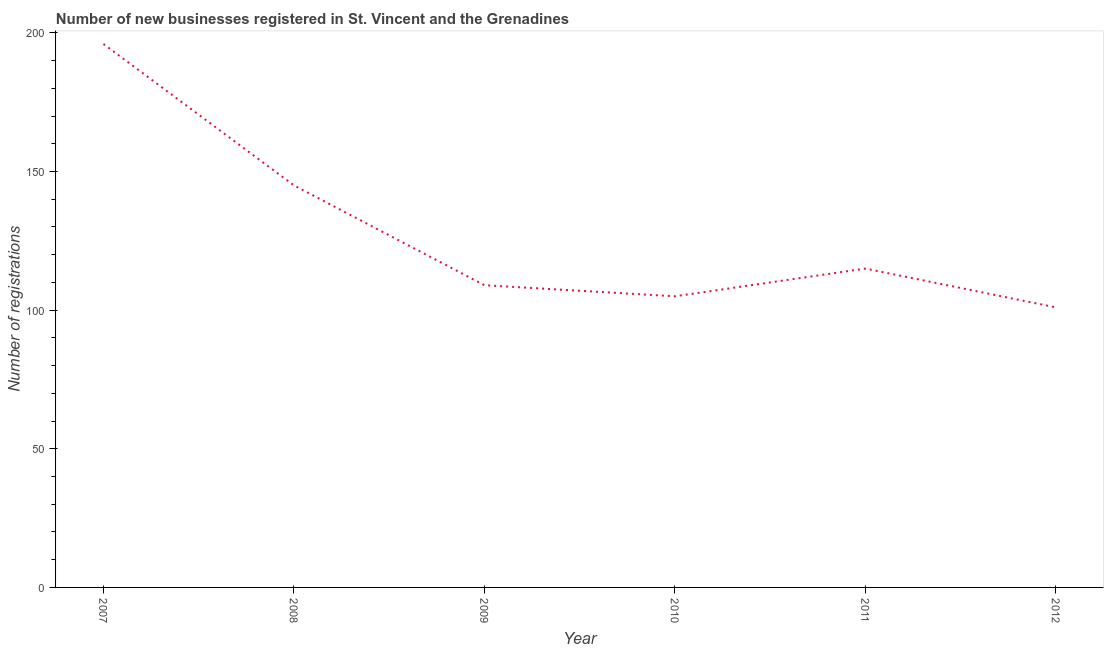What is the number of new business registrations in 2010?
Give a very brief answer. 105. Across all years, what is the maximum number of new business registrations?
Your answer should be compact. 196. Across all years, what is the minimum number of new business registrations?
Keep it short and to the point. 101. In which year was the number of new business registrations minimum?
Offer a terse response. 2012. What is the sum of the number of new business registrations?
Ensure brevity in your answer.  771. What is the difference between the number of new business registrations in 2010 and 2011?
Provide a short and direct response. -10. What is the average number of new business registrations per year?
Keep it short and to the point. 128.5. What is the median number of new business registrations?
Your answer should be very brief. 112. What is the ratio of the number of new business registrations in 2007 to that in 2011?
Ensure brevity in your answer.  1.7. Is the number of new business registrations in 2008 less than that in 2011?
Your answer should be compact. No. Is the difference between the number of new business registrations in 2007 and 2008 greater than the difference between any two years?
Provide a short and direct response. No. Is the sum of the number of new business registrations in 2007 and 2012 greater than the maximum number of new business registrations across all years?
Provide a succinct answer. Yes. What is the difference between the highest and the lowest number of new business registrations?
Make the answer very short. 95. In how many years, is the number of new business registrations greater than the average number of new business registrations taken over all years?
Provide a succinct answer. 2. How many lines are there?
Your answer should be very brief. 1. How many years are there in the graph?
Provide a short and direct response. 6. What is the difference between two consecutive major ticks on the Y-axis?
Offer a terse response. 50. Does the graph contain grids?
Give a very brief answer. No. What is the title of the graph?
Offer a terse response. Number of new businesses registered in St. Vincent and the Grenadines. What is the label or title of the Y-axis?
Keep it short and to the point. Number of registrations. What is the Number of registrations of 2007?
Offer a very short reply. 196. What is the Number of registrations of 2008?
Offer a very short reply. 145. What is the Number of registrations in 2009?
Your response must be concise. 109. What is the Number of registrations of 2010?
Your answer should be very brief. 105. What is the Number of registrations in 2011?
Ensure brevity in your answer.  115. What is the Number of registrations in 2012?
Offer a terse response. 101. What is the difference between the Number of registrations in 2007 and 2008?
Your answer should be compact. 51. What is the difference between the Number of registrations in 2007 and 2010?
Your answer should be compact. 91. What is the difference between the Number of registrations in 2008 and 2011?
Make the answer very short. 30. What is the difference between the Number of registrations in 2009 and 2012?
Ensure brevity in your answer.  8. What is the difference between the Number of registrations in 2010 and 2012?
Provide a short and direct response. 4. What is the difference between the Number of registrations in 2011 and 2012?
Make the answer very short. 14. What is the ratio of the Number of registrations in 2007 to that in 2008?
Your answer should be compact. 1.35. What is the ratio of the Number of registrations in 2007 to that in 2009?
Offer a terse response. 1.8. What is the ratio of the Number of registrations in 2007 to that in 2010?
Your answer should be compact. 1.87. What is the ratio of the Number of registrations in 2007 to that in 2011?
Your answer should be compact. 1.7. What is the ratio of the Number of registrations in 2007 to that in 2012?
Provide a short and direct response. 1.94. What is the ratio of the Number of registrations in 2008 to that in 2009?
Keep it short and to the point. 1.33. What is the ratio of the Number of registrations in 2008 to that in 2010?
Offer a very short reply. 1.38. What is the ratio of the Number of registrations in 2008 to that in 2011?
Keep it short and to the point. 1.26. What is the ratio of the Number of registrations in 2008 to that in 2012?
Offer a very short reply. 1.44. What is the ratio of the Number of registrations in 2009 to that in 2010?
Offer a terse response. 1.04. What is the ratio of the Number of registrations in 2009 to that in 2011?
Your answer should be very brief. 0.95. What is the ratio of the Number of registrations in 2009 to that in 2012?
Give a very brief answer. 1.08. What is the ratio of the Number of registrations in 2010 to that in 2011?
Your response must be concise. 0.91. What is the ratio of the Number of registrations in 2011 to that in 2012?
Keep it short and to the point. 1.14. 